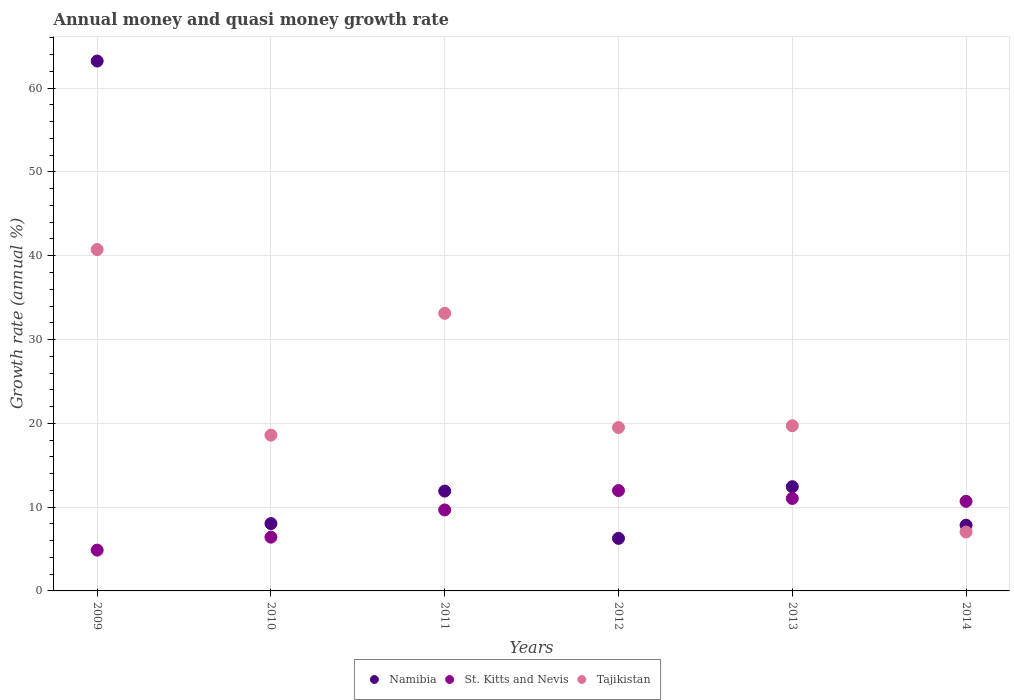Is the number of dotlines equal to the number of legend labels?
Your answer should be very brief. Yes. What is the growth rate in Namibia in 2013?
Provide a succinct answer. 12.44. Across all years, what is the maximum growth rate in Tajikistan?
Your response must be concise. 40.74. Across all years, what is the minimum growth rate in Namibia?
Provide a succinct answer. 6.27. In which year was the growth rate in Namibia maximum?
Offer a very short reply. 2009. In which year was the growth rate in Namibia minimum?
Offer a very short reply. 2012. What is the total growth rate in Namibia in the graph?
Keep it short and to the point. 109.74. What is the difference between the growth rate in Namibia in 2011 and that in 2013?
Your answer should be very brief. -0.52. What is the difference between the growth rate in Tajikistan in 2011 and the growth rate in St. Kitts and Nevis in 2012?
Provide a succinct answer. 21.16. What is the average growth rate in St. Kitts and Nevis per year?
Your response must be concise. 9.11. In the year 2013, what is the difference between the growth rate in St. Kitts and Nevis and growth rate in Namibia?
Provide a succinct answer. -1.4. What is the ratio of the growth rate in Namibia in 2010 to that in 2012?
Your response must be concise. 1.28. Is the growth rate in St. Kitts and Nevis in 2011 less than that in 2013?
Ensure brevity in your answer.  Yes. Is the difference between the growth rate in St. Kitts and Nevis in 2012 and 2013 greater than the difference between the growth rate in Namibia in 2012 and 2013?
Provide a succinct answer. Yes. What is the difference between the highest and the second highest growth rate in St. Kitts and Nevis?
Offer a very short reply. 0.94. What is the difference between the highest and the lowest growth rate in St. Kitts and Nevis?
Ensure brevity in your answer.  7.1. Is the sum of the growth rate in Namibia in 2009 and 2013 greater than the maximum growth rate in St. Kitts and Nevis across all years?
Your response must be concise. Yes. Is it the case that in every year, the sum of the growth rate in Namibia and growth rate in St. Kitts and Nevis  is greater than the growth rate in Tajikistan?
Your answer should be very brief. No. Does the growth rate in Namibia monotonically increase over the years?
Your answer should be very brief. No. What is the difference between two consecutive major ticks on the Y-axis?
Provide a succinct answer. 10. Does the graph contain grids?
Ensure brevity in your answer.  Yes. Where does the legend appear in the graph?
Give a very brief answer. Bottom center. How many legend labels are there?
Make the answer very short. 3. What is the title of the graph?
Make the answer very short. Annual money and quasi money growth rate. What is the label or title of the X-axis?
Your response must be concise. Years. What is the label or title of the Y-axis?
Offer a very short reply. Growth rate (annual %). What is the Growth rate (annual %) in Namibia in 2009?
Your answer should be very brief. 63.24. What is the Growth rate (annual %) in St. Kitts and Nevis in 2009?
Your response must be concise. 4.87. What is the Growth rate (annual %) of Tajikistan in 2009?
Provide a short and direct response. 40.74. What is the Growth rate (annual %) of Namibia in 2010?
Your answer should be very brief. 8.04. What is the Growth rate (annual %) in St. Kitts and Nevis in 2010?
Your response must be concise. 6.41. What is the Growth rate (annual %) in Tajikistan in 2010?
Keep it short and to the point. 18.59. What is the Growth rate (annual %) of Namibia in 2011?
Your response must be concise. 11.91. What is the Growth rate (annual %) of St. Kitts and Nevis in 2011?
Your response must be concise. 9.66. What is the Growth rate (annual %) in Tajikistan in 2011?
Your response must be concise. 33.13. What is the Growth rate (annual %) in Namibia in 2012?
Your answer should be compact. 6.27. What is the Growth rate (annual %) of St. Kitts and Nevis in 2012?
Make the answer very short. 11.97. What is the Growth rate (annual %) in Tajikistan in 2012?
Offer a very short reply. 19.5. What is the Growth rate (annual %) of Namibia in 2013?
Make the answer very short. 12.44. What is the Growth rate (annual %) in St. Kitts and Nevis in 2013?
Give a very brief answer. 11.04. What is the Growth rate (annual %) in Tajikistan in 2013?
Make the answer very short. 19.71. What is the Growth rate (annual %) in Namibia in 2014?
Keep it short and to the point. 7.84. What is the Growth rate (annual %) of St. Kitts and Nevis in 2014?
Keep it short and to the point. 10.69. What is the Growth rate (annual %) of Tajikistan in 2014?
Your answer should be compact. 7.03. Across all years, what is the maximum Growth rate (annual %) of Namibia?
Keep it short and to the point. 63.24. Across all years, what is the maximum Growth rate (annual %) of St. Kitts and Nevis?
Keep it short and to the point. 11.97. Across all years, what is the maximum Growth rate (annual %) in Tajikistan?
Your response must be concise. 40.74. Across all years, what is the minimum Growth rate (annual %) in Namibia?
Provide a short and direct response. 6.27. Across all years, what is the minimum Growth rate (annual %) of St. Kitts and Nevis?
Ensure brevity in your answer.  4.87. Across all years, what is the minimum Growth rate (annual %) in Tajikistan?
Give a very brief answer. 7.03. What is the total Growth rate (annual %) of Namibia in the graph?
Your answer should be very brief. 109.74. What is the total Growth rate (annual %) of St. Kitts and Nevis in the graph?
Make the answer very short. 54.65. What is the total Growth rate (annual %) in Tajikistan in the graph?
Keep it short and to the point. 138.71. What is the difference between the Growth rate (annual %) in Namibia in 2009 and that in 2010?
Ensure brevity in your answer.  55.2. What is the difference between the Growth rate (annual %) in St. Kitts and Nevis in 2009 and that in 2010?
Offer a very short reply. -1.54. What is the difference between the Growth rate (annual %) of Tajikistan in 2009 and that in 2010?
Your answer should be very brief. 22.15. What is the difference between the Growth rate (annual %) of Namibia in 2009 and that in 2011?
Your answer should be very brief. 51.32. What is the difference between the Growth rate (annual %) in St. Kitts and Nevis in 2009 and that in 2011?
Make the answer very short. -4.79. What is the difference between the Growth rate (annual %) of Tajikistan in 2009 and that in 2011?
Provide a succinct answer. 7.61. What is the difference between the Growth rate (annual %) in Namibia in 2009 and that in 2012?
Make the answer very short. 56.96. What is the difference between the Growth rate (annual %) of St. Kitts and Nevis in 2009 and that in 2012?
Make the answer very short. -7.1. What is the difference between the Growth rate (annual %) in Tajikistan in 2009 and that in 2012?
Your answer should be very brief. 21.24. What is the difference between the Growth rate (annual %) in Namibia in 2009 and that in 2013?
Make the answer very short. 50.8. What is the difference between the Growth rate (annual %) in St. Kitts and Nevis in 2009 and that in 2013?
Offer a very short reply. -6.17. What is the difference between the Growth rate (annual %) of Tajikistan in 2009 and that in 2013?
Keep it short and to the point. 21.03. What is the difference between the Growth rate (annual %) of Namibia in 2009 and that in 2014?
Offer a terse response. 55.39. What is the difference between the Growth rate (annual %) of St. Kitts and Nevis in 2009 and that in 2014?
Your answer should be compact. -5.82. What is the difference between the Growth rate (annual %) of Tajikistan in 2009 and that in 2014?
Offer a terse response. 33.71. What is the difference between the Growth rate (annual %) in Namibia in 2010 and that in 2011?
Keep it short and to the point. -3.88. What is the difference between the Growth rate (annual %) in St. Kitts and Nevis in 2010 and that in 2011?
Your answer should be very brief. -3.25. What is the difference between the Growth rate (annual %) in Tajikistan in 2010 and that in 2011?
Ensure brevity in your answer.  -14.54. What is the difference between the Growth rate (annual %) in Namibia in 2010 and that in 2012?
Offer a very short reply. 1.76. What is the difference between the Growth rate (annual %) in St. Kitts and Nevis in 2010 and that in 2012?
Your response must be concise. -5.56. What is the difference between the Growth rate (annual %) of Tajikistan in 2010 and that in 2012?
Your answer should be compact. -0.91. What is the difference between the Growth rate (annual %) of Namibia in 2010 and that in 2013?
Your response must be concise. -4.4. What is the difference between the Growth rate (annual %) in St. Kitts and Nevis in 2010 and that in 2013?
Give a very brief answer. -4.62. What is the difference between the Growth rate (annual %) in Tajikistan in 2010 and that in 2013?
Ensure brevity in your answer.  -1.12. What is the difference between the Growth rate (annual %) of Namibia in 2010 and that in 2014?
Your response must be concise. 0.19. What is the difference between the Growth rate (annual %) of St. Kitts and Nevis in 2010 and that in 2014?
Provide a short and direct response. -4.28. What is the difference between the Growth rate (annual %) in Tajikistan in 2010 and that in 2014?
Make the answer very short. 11.56. What is the difference between the Growth rate (annual %) of Namibia in 2011 and that in 2012?
Offer a very short reply. 5.64. What is the difference between the Growth rate (annual %) in St. Kitts and Nevis in 2011 and that in 2012?
Give a very brief answer. -2.31. What is the difference between the Growth rate (annual %) of Tajikistan in 2011 and that in 2012?
Offer a very short reply. 13.63. What is the difference between the Growth rate (annual %) of Namibia in 2011 and that in 2013?
Ensure brevity in your answer.  -0.52. What is the difference between the Growth rate (annual %) in St. Kitts and Nevis in 2011 and that in 2013?
Make the answer very short. -1.37. What is the difference between the Growth rate (annual %) of Tajikistan in 2011 and that in 2013?
Offer a terse response. 13.42. What is the difference between the Growth rate (annual %) in Namibia in 2011 and that in 2014?
Offer a terse response. 4.07. What is the difference between the Growth rate (annual %) in St. Kitts and Nevis in 2011 and that in 2014?
Keep it short and to the point. -1.03. What is the difference between the Growth rate (annual %) in Tajikistan in 2011 and that in 2014?
Your answer should be compact. 26.1. What is the difference between the Growth rate (annual %) in Namibia in 2012 and that in 2013?
Offer a terse response. -6.16. What is the difference between the Growth rate (annual %) in St. Kitts and Nevis in 2012 and that in 2013?
Your response must be concise. 0.94. What is the difference between the Growth rate (annual %) of Tajikistan in 2012 and that in 2013?
Provide a short and direct response. -0.21. What is the difference between the Growth rate (annual %) of Namibia in 2012 and that in 2014?
Your response must be concise. -1.57. What is the difference between the Growth rate (annual %) of St. Kitts and Nevis in 2012 and that in 2014?
Offer a terse response. 1.28. What is the difference between the Growth rate (annual %) in Tajikistan in 2012 and that in 2014?
Keep it short and to the point. 12.47. What is the difference between the Growth rate (annual %) in Namibia in 2013 and that in 2014?
Your answer should be very brief. 4.59. What is the difference between the Growth rate (annual %) of St. Kitts and Nevis in 2013 and that in 2014?
Ensure brevity in your answer.  0.34. What is the difference between the Growth rate (annual %) of Tajikistan in 2013 and that in 2014?
Your response must be concise. 12.68. What is the difference between the Growth rate (annual %) in Namibia in 2009 and the Growth rate (annual %) in St. Kitts and Nevis in 2010?
Keep it short and to the point. 56.82. What is the difference between the Growth rate (annual %) of Namibia in 2009 and the Growth rate (annual %) of Tajikistan in 2010?
Your answer should be compact. 44.65. What is the difference between the Growth rate (annual %) of St. Kitts and Nevis in 2009 and the Growth rate (annual %) of Tajikistan in 2010?
Keep it short and to the point. -13.72. What is the difference between the Growth rate (annual %) in Namibia in 2009 and the Growth rate (annual %) in St. Kitts and Nevis in 2011?
Your response must be concise. 53.57. What is the difference between the Growth rate (annual %) in Namibia in 2009 and the Growth rate (annual %) in Tajikistan in 2011?
Your answer should be compact. 30.1. What is the difference between the Growth rate (annual %) in St. Kitts and Nevis in 2009 and the Growth rate (annual %) in Tajikistan in 2011?
Provide a succinct answer. -28.26. What is the difference between the Growth rate (annual %) of Namibia in 2009 and the Growth rate (annual %) of St. Kitts and Nevis in 2012?
Provide a short and direct response. 51.26. What is the difference between the Growth rate (annual %) of Namibia in 2009 and the Growth rate (annual %) of Tajikistan in 2012?
Ensure brevity in your answer.  43.74. What is the difference between the Growth rate (annual %) of St. Kitts and Nevis in 2009 and the Growth rate (annual %) of Tajikistan in 2012?
Offer a very short reply. -14.63. What is the difference between the Growth rate (annual %) of Namibia in 2009 and the Growth rate (annual %) of St. Kitts and Nevis in 2013?
Make the answer very short. 52.2. What is the difference between the Growth rate (annual %) in Namibia in 2009 and the Growth rate (annual %) in Tajikistan in 2013?
Your answer should be compact. 43.52. What is the difference between the Growth rate (annual %) in St. Kitts and Nevis in 2009 and the Growth rate (annual %) in Tajikistan in 2013?
Your answer should be compact. -14.84. What is the difference between the Growth rate (annual %) of Namibia in 2009 and the Growth rate (annual %) of St. Kitts and Nevis in 2014?
Provide a succinct answer. 52.54. What is the difference between the Growth rate (annual %) in Namibia in 2009 and the Growth rate (annual %) in Tajikistan in 2014?
Make the answer very short. 56.2. What is the difference between the Growth rate (annual %) of St. Kitts and Nevis in 2009 and the Growth rate (annual %) of Tajikistan in 2014?
Provide a succinct answer. -2.16. What is the difference between the Growth rate (annual %) in Namibia in 2010 and the Growth rate (annual %) in St. Kitts and Nevis in 2011?
Provide a succinct answer. -1.63. What is the difference between the Growth rate (annual %) of Namibia in 2010 and the Growth rate (annual %) of Tajikistan in 2011?
Keep it short and to the point. -25.09. What is the difference between the Growth rate (annual %) in St. Kitts and Nevis in 2010 and the Growth rate (annual %) in Tajikistan in 2011?
Your answer should be compact. -26.72. What is the difference between the Growth rate (annual %) in Namibia in 2010 and the Growth rate (annual %) in St. Kitts and Nevis in 2012?
Offer a very short reply. -3.94. What is the difference between the Growth rate (annual %) in Namibia in 2010 and the Growth rate (annual %) in Tajikistan in 2012?
Give a very brief answer. -11.46. What is the difference between the Growth rate (annual %) in St. Kitts and Nevis in 2010 and the Growth rate (annual %) in Tajikistan in 2012?
Provide a succinct answer. -13.08. What is the difference between the Growth rate (annual %) in Namibia in 2010 and the Growth rate (annual %) in St. Kitts and Nevis in 2013?
Your response must be concise. -3. What is the difference between the Growth rate (annual %) in Namibia in 2010 and the Growth rate (annual %) in Tajikistan in 2013?
Offer a terse response. -11.68. What is the difference between the Growth rate (annual %) of St. Kitts and Nevis in 2010 and the Growth rate (annual %) of Tajikistan in 2013?
Your answer should be very brief. -13.3. What is the difference between the Growth rate (annual %) of Namibia in 2010 and the Growth rate (annual %) of St. Kitts and Nevis in 2014?
Give a very brief answer. -2.66. What is the difference between the Growth rate (annual %) of St. Kitts and Nevis in 2010 and the Growth rate (annual %) of Tajikistan in 2014?
Keep it short and to the point. -0.62. What is the difference between the Growth rate (annual %) in Namibia in 2011 and the Growth rate (annual %) in St. Kitts and Nevis in 2012?
Offer a terse response. -0.06. What is the difference between the Growth rate (annual %) in Namibia in 2011 and the Growth rate (annual %) in Tajikistan in 2012?
Make the answer very short. -7.59. What is the difference between the Growth rate (annual %) of St. Kitts and Nevis in 2011 and the Growth rate (annual %) of Tajikistan in 2012?
Give a very brief answer. -9.84. What is the difference between the Growth rate (annual %) in Namibia in 2011 and the Growth rate (annual %) in St. Kitts and Nevis in 2013?
Your response must be concise. 0.88. What is the difference between the Growth rate (annual %) of Namibia in 2011 and the Growth rate (annual %) of Tajikistan in 2013?
Make the answer very short. -7.8. What is the difference between the Growth rate (annual %) in St. Kitts and Nevis in 2011 and the Growth rate (annual %) in Tajikistan in 2013?
Keep it short and to the point. -10.05. What is the difference between the Growth rate (annual %) in Namibia in 2011 and the Growth rate (annual %) in St. Kitts and Nevis in 2014?
Your answer should be compact. 1.22. What is the difference between the Growth rate (annual %) in Namibia in 2011 and the Growth rate (annual %) in Tajikistan in 2014?
Provide a short and direct response. 4.88. What is the difference between the Growth rate (annual %) of St. Kitts and Nevis in 2011 and the Growth rate (annual %) of Tajikistan in 2014?
Your answer should be very brief. 2.63. What is the difference between the Growth rate (annual %) of Namibia in 2012 and the Growth rate (annual %) of St. Kitts and Nevis in 2013?
Keep it short and to the point. -4.76. What is the difference between the Growth rate (annual %) in Namibia in 2012 and the Growth rate (annual %) in Tajikistan in 2013?
Provide a short and direct response. -13.44. What is the difference between the Growth rate (annual %) of St. Kitts and Nevis in 2012 and the Growth rate (annual %) of Tajikistan in 2013?
Keep it short and to the point. -7.74. What is the difference between the Growth rate (annual %) in Namibia in 2012 and the Growth rate (annual %) in St. Kitts and Nevis in 2014?
Provide a succinct answer. -4.42. What is the difference between the Growth rate (annual %) in Namibia in 2012 and the Growth rate (annual %) in Tajikistan in 2014?
Offer a terse response. -0.76. What is the difference between the Growth rate (annual %) of St. Kitts and Nevis in 2012 and the Growth rate (annual %) of Tajikistan in 2014?
Ensure brevity in your answer.  4.94. What is the difference between the Growth rate (annual %) in Namibia in 2013 and the Growth rate (annual %) in St. Kitts and Nevis in 2014?
Provide a succinct answer. 1.75. What is the difference between the Growth rate (annual %) of Namibia in 2013 and the Growth rate (annual %) of Tajikistan in 2014?
Your response must be concise. 5.4. What is the difference between the Growth rate (annual %) of St. Kitts and Nevis in 2013 and the Growth rate (annual %) of Tajikistan in 2014?
Keep it short and to the point. 4. What is the average Growth rate (annual %) in Namibia per year?
Provide a succinct answer. 18.29. What is the average Growth rate (annual %) of St. Kitts and Nevis per year?
Offer a very short reply. 9.11. What is the average Growth rate (annual %) of Tajikistan per year?
Your response must be concise. 23.12. In the year 2009, what is the difference between the Growth rate (annual %) of Namibia and Growth rate (annual %) of St. Kitts and Nevis?
Provide a succinct answer. 58.36. In the year 2009, what is the difference between the Growth rate (annual %) of Namibia and Growth rate (annual %) of Tajikistan?
Your response must be concise. 22.5. In the year 2009, what is the difference between the Growth rate (annual %) of St. Kitts and Nevis and Growth rate (annual %) of Tajikistan?
Ensure brevity in your answer.  -35.87. In the year 2010, what is the difference between the Growth rate (annual %) of Namibia and Growth rate (annual %) of St. Kitts and Nevis?
Your answer should be compact. 1.62. In the year 2010, what is the difference between the Growth rate (annual %) in Namibia and Growth rate (annual %) in Tajikistan?
Provide a short and direct response. -10.55. In the year 2010, what is the difference between the Growth rate (annual %) of St. Kitts and Nevis and Growth rate (annual %) of Tajikistan?
Your answer should be very brief. -12.17. In the year 2011, what is the difference between the Growth rate (annual %) in Namibia and Growth rate (annual %) in St. Kitts and Nevis?
Your answer should be compact. 2.25. In the year 2011, what is the difference between the Growth rate (annual %) in Namibia and Growth rate (annual %) in Tajikistan?
Ensure brevity in your answer.  -21.22. In the year 2011, what is the difference between the Growth rate (annual %) in St. Kitts and Nevis and Growth rate (annual %) in Tajikistan?
Offer a very short reply. -23.47. In the year 2012, what is the difference between the Growth rate (annual %) in Namibia and Growth rate (annual %) in St. Kitts and Nevis?
Your answer should be compact. -5.7. In the year 2012, what is the difference between the Growth rate (annual %) in Namibia and Growth rate (annual %) in Tajikistan?
Keep it short and to the point. -13.23. In the year 2012, what is the difference between the Growth rate (annual %) in St. Kitts and Nevis and Growth rate (annual %) in Tajikistan?
Make the answer very short. -7.53. In the year 2013, what is the difference between the Growth rate (annual %) of Namibia and Growth rate (annual %) of St. Kitts and Nevis?
Give a very brief answer. 1.4. In the year 2013, what is the difference between the Growth rate (annual %) in Namibia and Growth rate (annual %) in Tajikistan?
Offer a very short reply. -7.28. In the year 2013, what is the difference between the Growth rate (annual %) in St. Kitts and Nevis and Growth rate (annual %) in Tajikistan?
Your response must be concise. -8.68. In the year 2014, what is the difference between the Growth rate (annual %) of Namibia and Growth rate (annual %) of St. Kitts and Nevis?
Your answer should be compact. -2.85. In the year 2014, what is the difference between the Growth rate (annual %) in Namibia and Growth rate (annual %) in Tajikistan?
Your answer should be very brief. 0.81. In the year 2014, what is the difference between the Growth rate (annual %) of St. Kitts and Nevis and Growth rate (annual %) of Tajikistan?
Provide a succinct answer. 3.66. What is the ratio of the Growth rate (annual %) of Namibia in 2009 to that in 2010?
Offer a very short reply. 7.87. What is the ratio of the Growth rate (annual %) in St. Kitts and Nevis in 2009 to that in 2010?
Make the answer very short. 0.76. What is the ratio of the Growth rate (annual %) of Tajikistan in 2009 to that in 2010?
Your answer should be very brief. 2.19. What is the ratio of the Growth rate (annual %) of Namibia in 2009 to that in 2011?
Keep it short and to the point. 5.31. What is the ratio of the Growth rate (annual %) of St. Kitts and Nevis in 2009 to that in 2011?
Keep it short and to the point. 0.5. What is the ratio of the Growth rate (annual %) in Tajikistan in 2009 to that in 2011?
Your response must be concise. 1.23. What is the ratio of the Growth rate (annual %) of Namibia in 2009 to that in 2012?
Give a very brief answer. 10.08. What is the ratio of the Growth rate (annual %) in St. Kitts and Nevis in 2009 to that in 2012?
Make the answer very short. 0.41. What is the ratio of the Growth rate (annual %) of Tajikistan in 2009 to that in 2012?
Provide a succinct answer. 2.09. What is the ratio of the Growth rate (annual %) in Namibia in 2009 to that in 2013?
Keep it short and to the point. 5.08. What is the ratio of the Growth rate (annual %) of St. Kitts and Nevis in 2009 to that in 2013?
Provide a succinct answer. 0.44. What is the ratio of the Growth rate (annual %) in Tajikistan in 2009 to that in 2013?
Provide a short and direct response. 2.07. What is the ratio of the Growth rate (annual %) in Namibia in 2009 to that in 2014?
Offer a terse response. 8.06. What is the ratio of the Growth rate (annual %) of St. Kitts and Nevis in 2009 to that in 2014?
Your response must be concise. 0.46. What is the ratio of the Growth rate (annual %) of Tajikistan in 2009 to that in 2014?
Ensure brevity in your answer.  5.79. What is the ratio of the Growth rate (annual %) in Namibia in 2010 to that in 2011?
Make the answer very short. 0.67. What is the ratio of the Growth rate (annual %) of St. Kitts and Nevis in 2010 to that in 2011?
Provide a short and direct response. 0.66. What is the ratio of the Growth rate (annual %) in Tajikistan in 2010 to that in 2011?
Your answer should be compact. 0.56. What is the ratio of the Growth rate (annual %) of Namibia in 2010 to that in 2012?
Ensure brevity in your answer.  1.28. What is the ratio of the Growth rate (annual %) of St. Kitts and Nevis in 2010 to that in 2012?
Ensure brevity in your answer.  0.54. What is the ratio of the Growth rate (annual %) in Tajikistan in 2010 to that in 2012?
Offer a terse response. 0.95. What is the ratio of the Growth rate (annual %) of Namibia in 2010 to that in 2013?
Your response must be concise. 0.65. What is the ratio of the Growth rate (annual %) in St. Kitts and Nevis in 2010 to that in 2013?
Your response must be concise. 0.58. What is the ratio of the Growth rate (annual %) in Tajikistan in 2010 to that in 2013?
Your response must be concise. 0.94. What is the ratio of the Growth rate (annual %) in Namibia in 2010 to that in 2014?
Your response must be concise. 1.02. What is the ratio of the Growth rate (annual %) in St. Kitts and Nevis in 2010 to that in 2014?
Offer a terse response. 0.6. What is the ratio of the Growth rate (annual %) in Tajikistan in 2010 to that in 2014?
Ensure brevity in your answer.  2.64. What is the ratio of the Growth rate (annual %) in Namibia in 2011 to that in 2012?
Ensure brevity in your answer.  1.9. What is the ratio of the Growth rate (annual %) in St. Kitts and Nevis in 2011 to that in 2012?
Ensure brevity in your answer.  0.81. What is the ratio of the Growth rate (annual %) in Tajikistan in 2011 to that in 2012?
Ensure brevity in your answer.  1.7. What is the ratio of the Growth rate (annual %) in Namibia in 2011 to that in 2013?
Give a very brief answer. 0.96. What is the ratio of the Growth rate (annual %) in St. Kitts and Nevis in 2011 to that in 2013?
Your response must be concise. 0.88. What is the ratio of the Growth rate (annual %) in Tajikistan in 2011 to that in 2013?
Offer a terse response. 1.68. What is the ratio of the Growth rate (annual %) of Namibia in 2011 to that in 2014?
Provide a succinct answer. 1.52. What is the ratio of the Growth rate (annual %) in St. Kitts and Nevis in 2011 to that in 2014?
Offer a very short reply. 0.9. What is the ratio of the Growth rate (annual %) in Tajikistan in 2011 to that in 2014?
Give a very brief answer. 4.71. What is the ratio of the Growth rate (annual %) of Namibia in 2012 to that in 2013?
Provide a succinct answer. 0.5. What is the ratio of the Growth rate (annual %) in St. Kitts and Nevis in 2012 to that in 2013?
Ensure brevity in your answer.  1.08. What is the ratio of the Growth rate (annual %) of Tajikistan in 2012 to that in 2013?
Provide a short and direct response. 0.99. What is the ratio of the Growth rate (annual %) in Namibia in 2012 to that in 2014?
Offer a very short reply. 0.8. What is the ratio of the Growth rate (annual %) of St. Kitts and Nevis in 2012 to that in 2014?
Keep it short and to the point. 1.12. What is the ratio of the Growth rate (annual %) of Tajikistan in 2012 to that in 2014?
Your answer should be compact. 2.77. What is the ratio of the Growth rate (annual %) of Namibia in 2013 to that in 2014?
Your answer should be compact. 1.59. What is the ratio of the Growth rate (annual %) of St. Kitts and Nevis in 2013 to that in 2014?
Provide a short and direct response. 1.03. What is the ratio of the Growth rate (annual %) of Tajikistan in 2013 to that in 2014?
Provide a succinct answer. 2.8. What is the difference between the highest and the second highest Growth rate (annual %) in Namibia?
Make the answer very short. 50.8. What is the difference between the highest and the second highest Growth rate (annual %) of St. Kitts and Nevis?
Your answer should be compact. 0.94. What is the difference between the highest and the second highest Growth rate (annual %) of Tajikistan?
Your response must be concise. 7.61. What is the difference between the highest and the lowest Growth rate (annual %) of Namibia?
Make the answer very short. 56.96. What is the difference between the highest and the lowest Growth rate (annual %) of St. Kitts and Nevis?
Provide a succinct answer. 7.1. What is the difference between the highest and the lowest Growth rate (annual %) of Tajikistan?
Your answer should be compact. 33.71. 